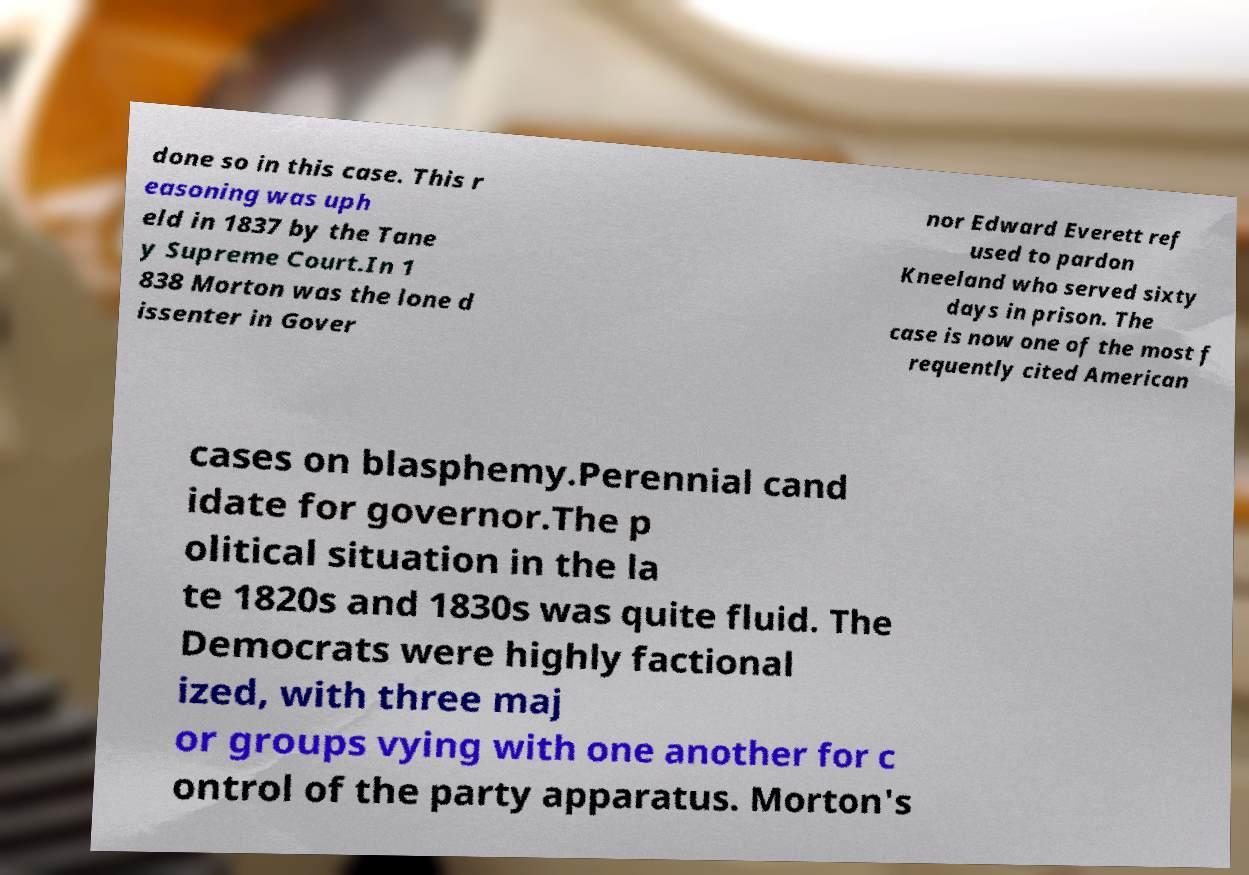Please identify and transcribe the text found in this image. done so in this case. This r easoning was uph eld in 1837 by the Tane y Supreme Court.In 1 838 Morton was the lone d issenter in Gover nor Edward Everett ref used to pardon Kneeland who served sixty days in prison. The case is now one of the most f requently cited American cases on blasphemy.Perennial cand idate for governor.The p olitical situation in the la te 1820s and 1830s was quite fluid. The Democrats were highly factional ized, with three maj or groups vying with one another for c ontrol of the party apparatus. Morton's 